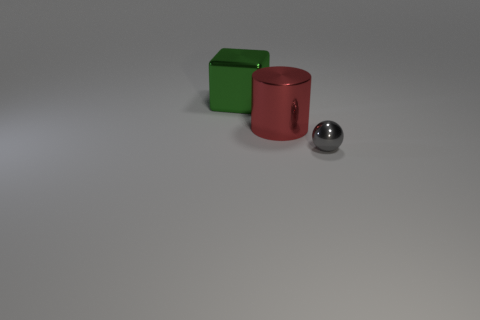Is there any other thing of the same color as the metallic cylinder?
Your response must be concise. No. What is the color of the large block?
Ensure brevity in your answer.  Green. Are any big cyan shiny balls visible?
Provide a short and direct response. No. Are there any tiny balls right of the shiny cube?
Your answer should be compact. Yes. Are there any other things that are the same material as the large red thing?
Offer a very short reply. Yes. How many other objects are there of the same shape as the tiny metallic thing?
Provide a succinct answer. 0. There is a big thing in front of the shiny thing on the left side of the big red cylinder; how many big things are in front of it?
Your answer should be very brief. 0. What number of other big objects are the same shape as the gray object?
Your answer should be very brief. 0. There is a large thing in front of the large metal cube; does it have the same color as the metallic sphere?
Provide a succinct answer. No. What shape is the big object on the right side of the big shiny thing to the left of the large thing in front of the green block?
Provide a short and direct response. Cylinder. 